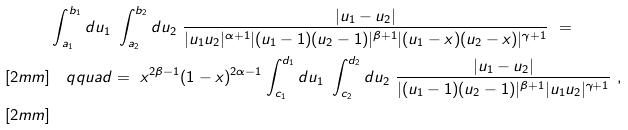<formula> <loc_0><loc_0><loc_500><loc_500>& \int _ { a _ { 1 } } ^ { b _ { 1 } } d u _ { 1 } \ \int _ { a _ { 2 } } ^ { b _ { 2 } } d u _ { 2 } \ \frac { | u _ { 1 } - u _ { 2 } | } { | u _ { 1 } u _ { 2 } | ^ { \alpha + 1 } | ( u _ { 1 } - 1 ) ( u _ { 2 } - 1 ) | ^ { \beta + 1 } | ( u _ { 1 } - x ) ( u _ { 2 } - x ) | ^ { \gamma + 1 } } \ = \\ [ 2 m m ] & \quad q q u a d = \ x ^ { 2 \beta - 1 } ( 1 - x ) ^ { 2 \alpha - 1 } \int _ { c _ { 1 } } ^ { d _ { 1 } } d u _ { 1 } \ \int _ { c _ { 2 } } ^ { d _ { 2 } } d u _ { 2 } \ \frac { | u _ { 1 } - u _ { 2 } | } { | ( u _ { 1 } - 1 ) ( u _ { 2 } - 1 ) | ^ { \beta + 1 } | u _ { 1 } u _ { 2 } | ^ { \gamma + 1 } } \ , \\ [ 2 m m ]</formula> 